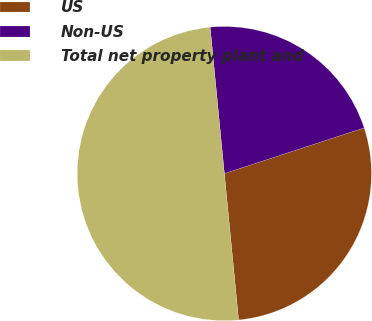Convert chart. <chart><loc_0><loc_0><loc_500><loc_500><pie_chart><fcel>US<fcel>Non-US<fcel>Total net property plant and<nl><fcel>28.49%<fcel>21.51%<fcel>50.0%<nl></chart> 